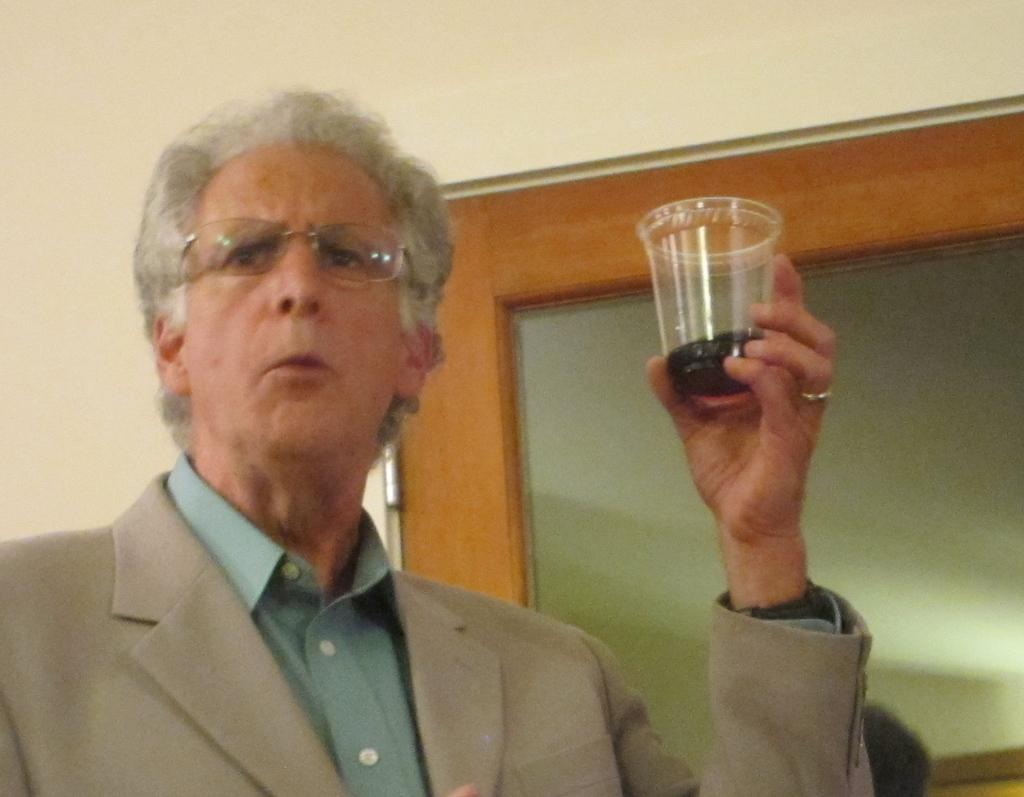Who is present in the image? There is a person in the image. What is the person wearing? The person is wearing a suit. What is the person holding in his hand? The person is holding a glass of drink in his hand. What type of celery is the person eating in the image? There is no celery present in the image; the person is holding a glass of drink. Why is the person crying in the image? The person is not crying in the image; there is no indication of any emotional state. 